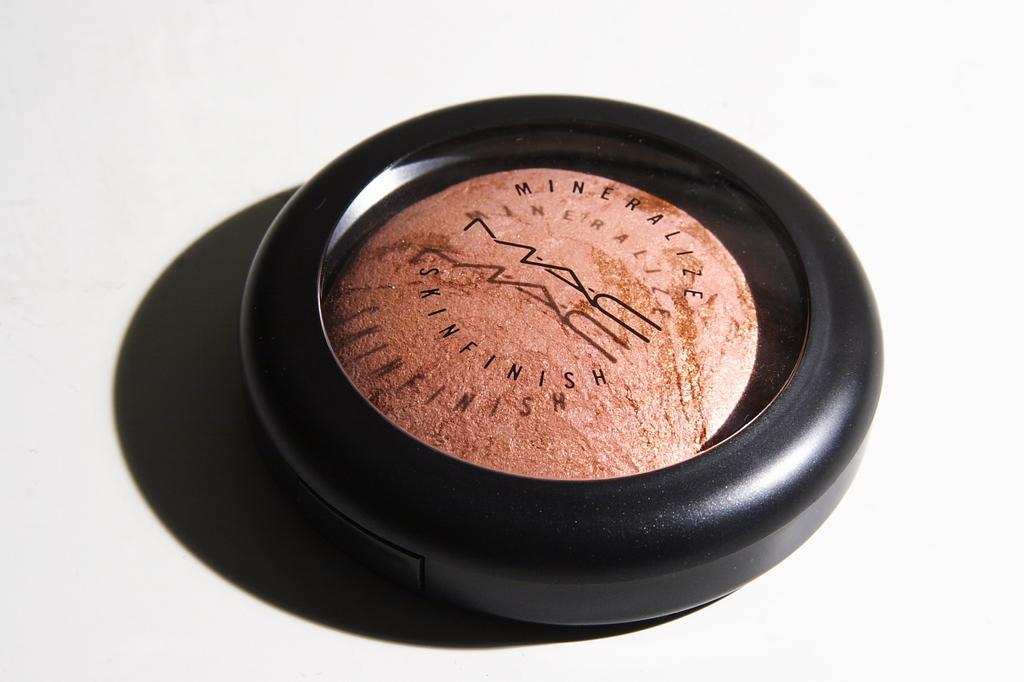<image>
Offer a succinct explanation of the picture presented. A fancy MAC skinfinish product displayed on a white background. 